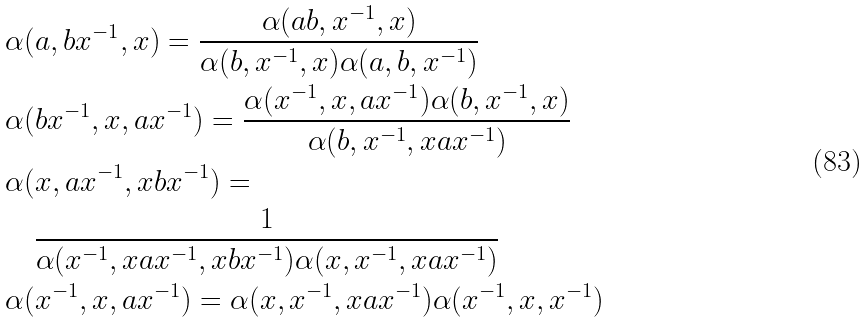<formula> <loc_0><loc_0><loc_500><loc_500>& \alpha ( a , b x ^ { - 1 } , x ) = \frac { \alpha ( a b , x ^ { - 1 } , x ) } { \alpha ( b , x ^ { - 1 } , x ) \alpha ( a , b , x ^ { - 1 } ) } \\ & \alpha ( b x ^ { - 1 } , x , a x ^ { - 1 } ) = \frac { \alpha ( x ^ { - 1 } , x , a x ^ { - 1 } ) \alpha ( b , x ^ { - 1 } , x ) } { \alpha ( b , x ^ { - 1 } , x a x ^ { - 1 } ) } \\ & \alpha ( x , a x ^ { - 1 } , x b x ^ { - 1 } ) = \\ & \quad \frac { 1 } { \alpha ( x ^ { - 1 } , x a x ^ { - 1 } , x b x ^ { - 1 } ) \alpha ( x , x ^ { - 1 } , x a x ^ { - 1 } ) } \\ & \alpha ( x ^ { - 1 } , x , a x ^ { - 1 } ) = \alpha ( x , x ^ { - 1 } , x a x ^ { - 1 } ) \alpha ( x ^ { - 1 } , x , x ^ { - 1 } )</formula> 